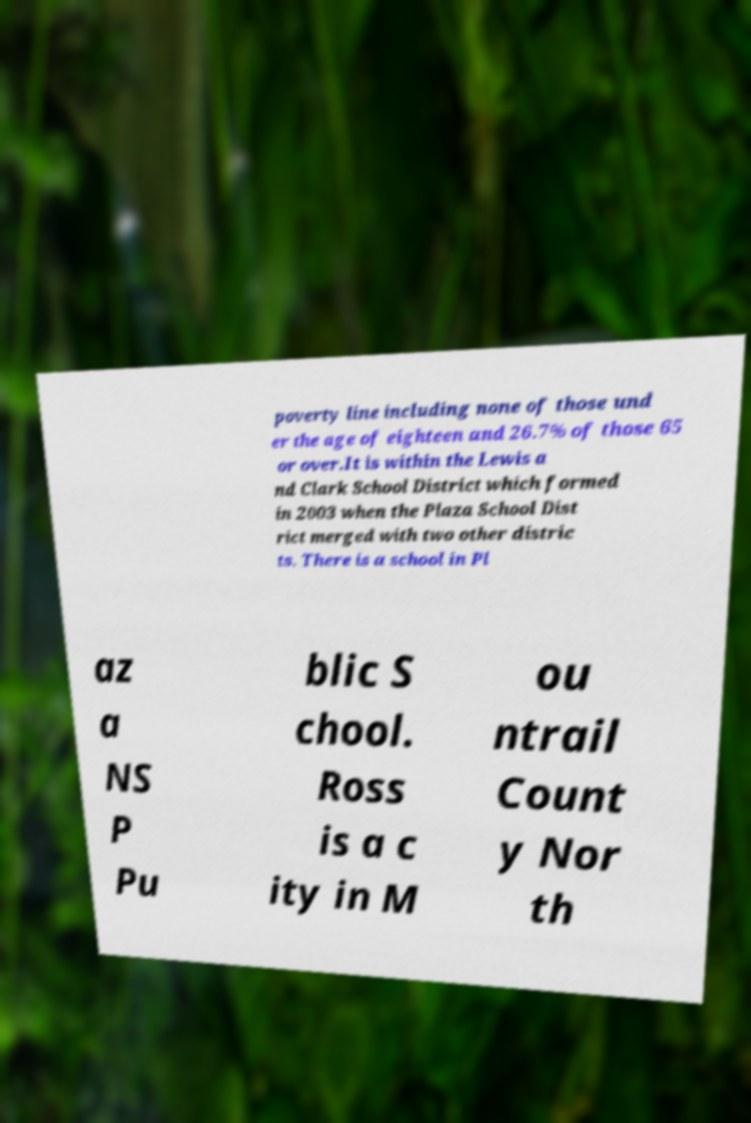Please identify and transcribe the text found in this image. poverty line including none of those und er the age of eighteen and 26.7% of those 65 or over.It is within the Lewis a nd Clark School District which formed in 2003 when the Plaza School Dist rict merged with two other distric ts. There is a school in Pl az a NS P Pu blic S chool. Ross is a c ity in M ou ntrail Count y Nor th 